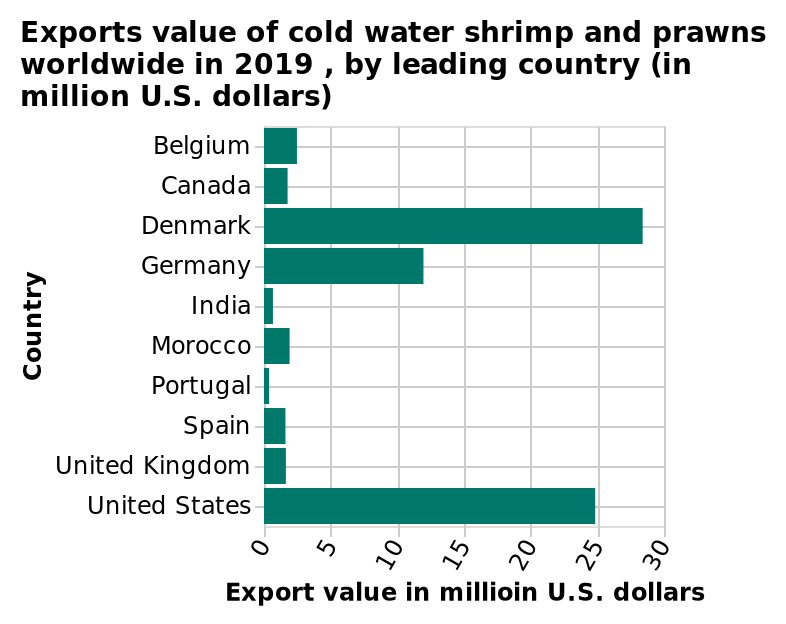<image>
What is the average export of the non-leaders in the market? The average export of the non-leaders in the market is ten times less than the leaders. 